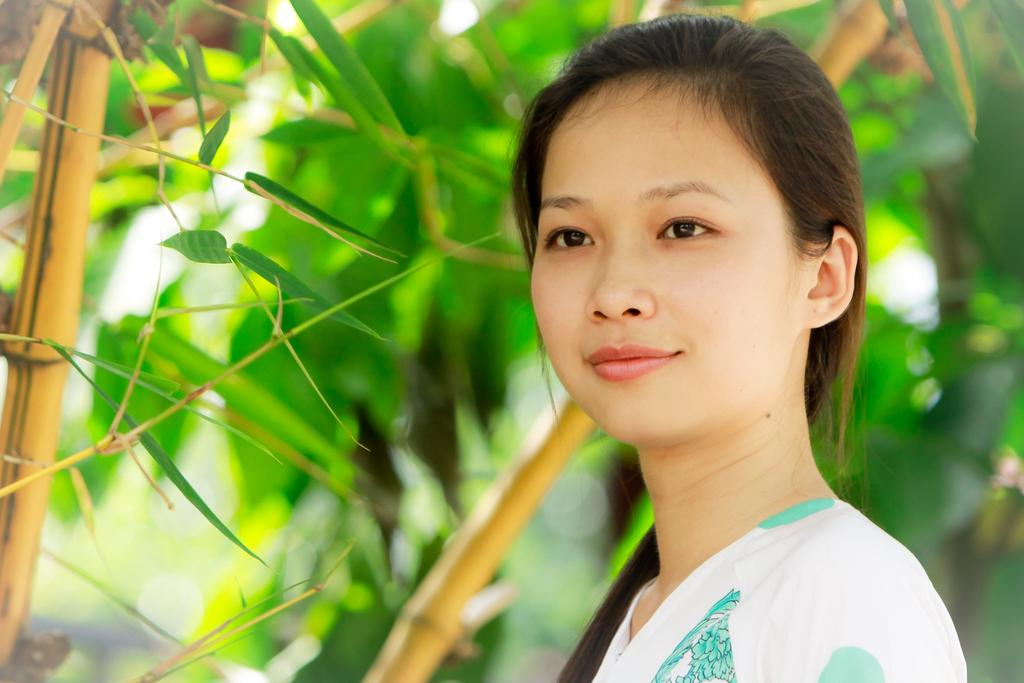Who is the main subject in the image? There is a lady in the image. Where is the lady located in the image? The lady is on the right side of the image. What can be seen in the background of the image? There are trees in the background of the image. How would you describe the background of the image? The background is blurry. How many kittens are sleeping on the bed in the image? There are no kittens or beds present in the image. 